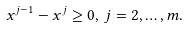<formula> <loc_0><loc_0><loc_500><loc_500>x ^ { j - 1 } - x ^ { j } \geq 0 , \, j = 2 , \dots , m .</formula> 